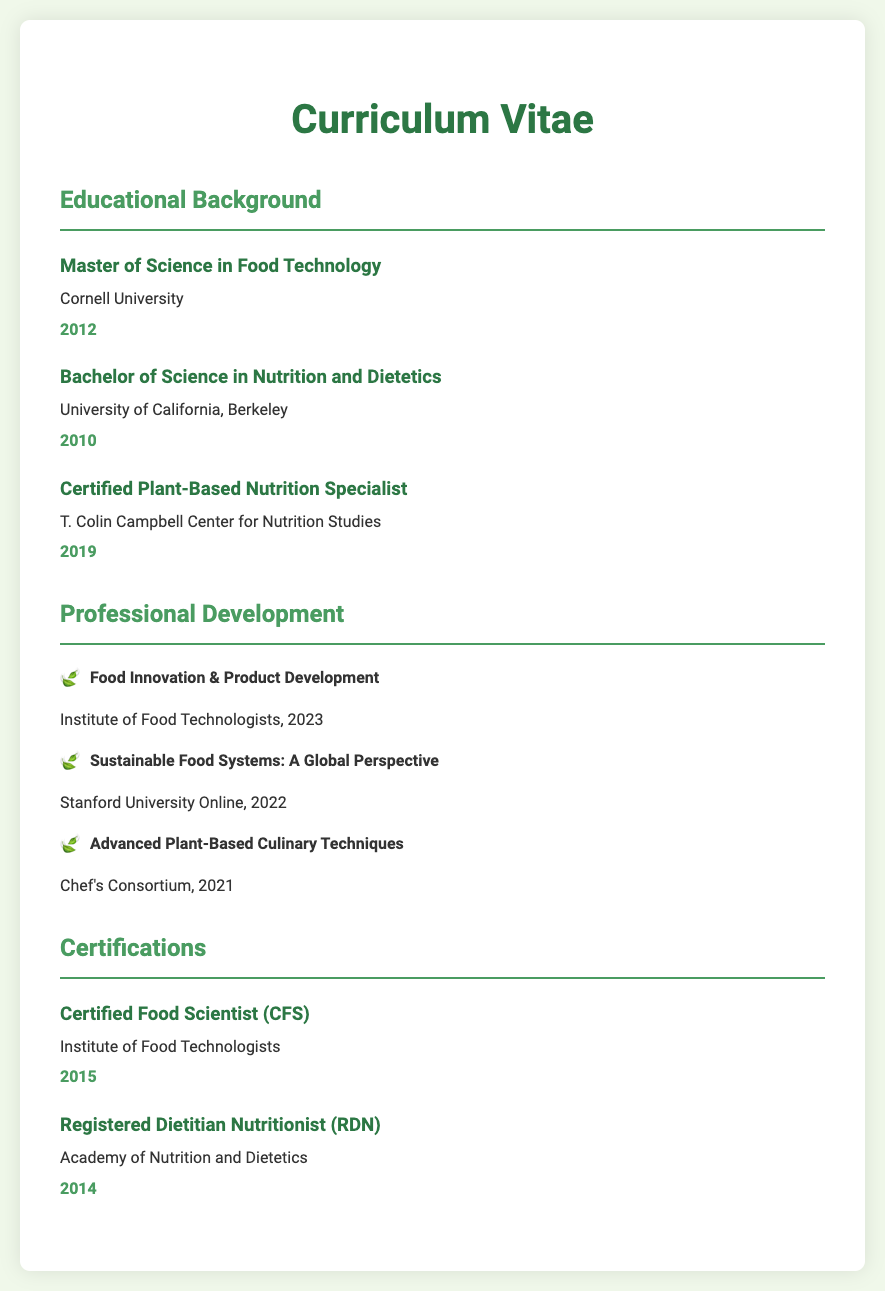what is the highest degree obtained? The highest degree obtained is the Master of Science in Food Technology, listed in the Educational Background section.
Answer: Master of Science in Food Technology which university awarded the Bachelor's degree? The Bachelor's degree was awarded by the University of California, Berkeley, as mentioned in the Educational Background section.
Answer: University of California, Berkeley when did the individual obtain the Certified Plant-Based Nutrition Specialist certification? The year for obtaining the Certified Plant-Based Nutrition Specialist certification is found in the Educational Background section.
Answer: 2019 how many professional development courses are listed? The number of professional development courses can be counted from the Professional Development section of the document.
Answer: 3 what was the year of the Certified Food Scientist certification? The year for the Certified Food Scientist certification is provided in the Certifications section of the document.
Answer: 2015 which institution is the Certified Plant-Based Nutrition Specialist associated with? The institution for the Certified Plant-Based Nutrition Specialist is mentioned in the Educational Background section.
Answer: T. Colin Campbell Center for Nutrition Studies list one of the professional development courses completed in 2022. One professional development course completed in 2022 is stated in the Professional Development section.
Answer: Sustainable Food Systems: A Global Perspective who oversees the Registered Dietitian Nutritionist certification? The overseeing body for the Registered Dietitian Nutritionist certification is located in the Certifications section.
Answer: Academy of Nutrition and Dietetics 